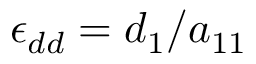<formula> <loc_0><loc_0><loc_500><loc_500>\epsilon _ { d d } = d _ { 1 } / a _ { 1 1 }</formula> 